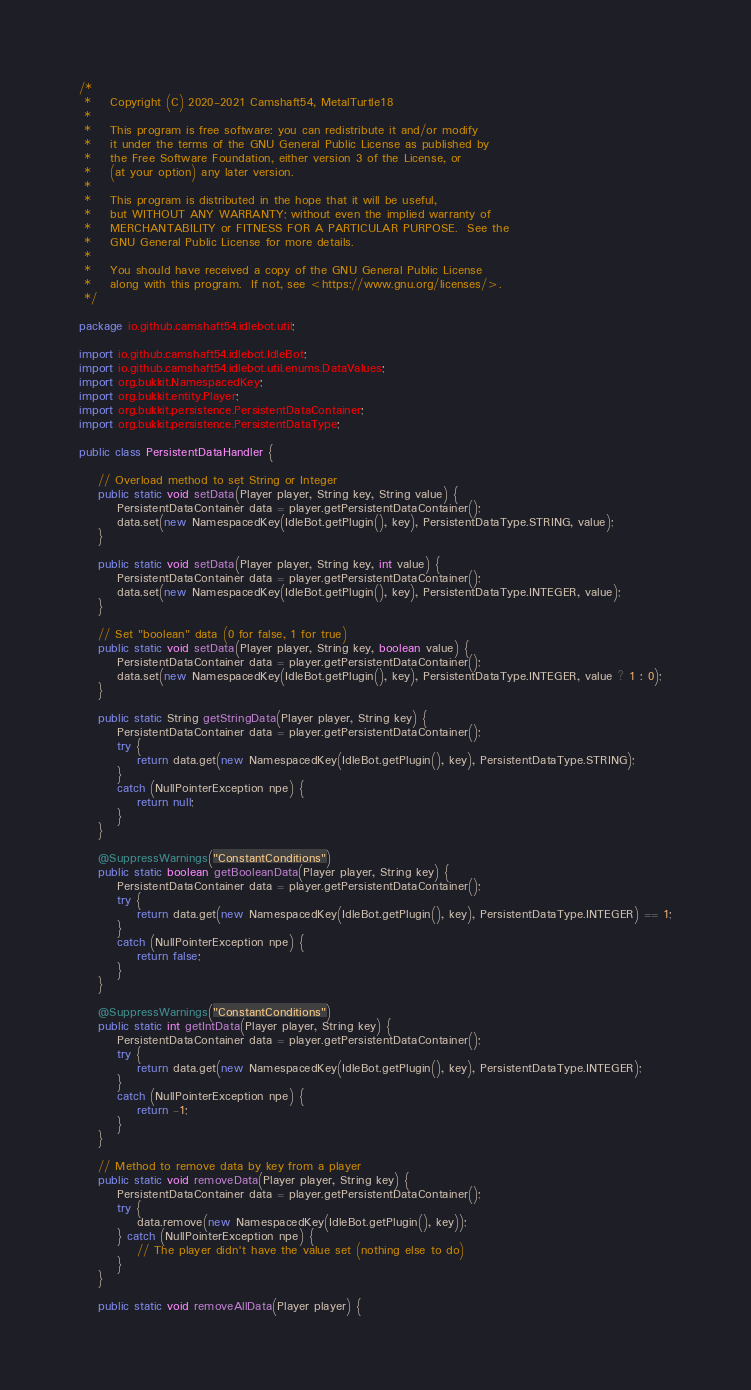Convert code to text. <code><loc_0><loc_0><loc_500><loc_500><_Java_>/*
 *    Copyright (C) 2020-2021 Camshaft54, MetalTurtle18
 *
 *    This program is free software: you can redistribute it and/or modify
 *    it under the terms of the GNU General Public License as published by
 *    the Free Software Foundation, either version 3 of the License, or
 *    (at your option) any later version.
 *
 *    This program is distributed in the hope that it will be useful,
 *    but WITHOUT ANY WARRANTY; without even the implied warranty of
 *    MERCHANTABILITY or FITNESS FOR A PARTICULAR PURPOSE.  See the
 *    GNU General Public License for more details.
 *
 *    You should have received a copy of the GNU General Public License
 *    along with this program.  If not, see <https://www.gnu.org/licenses/>.
 */

package io.github.camshaft54.idlebot.util;

import io.github.camshaft54.idlebot.IdleBot;
import io.github.camshaft54.idlebot.util.enums.DataValues;
import org.bukkit.NamespacedKey;
import org.bukkit.entity.Player;
import org.bukkit.persistence.PersistentDataContainer;
import org.bukkit.persistence.PersistentDataType;

public class PersistentDataHandler {

    // Overload method to set String or Integer
    public static void setData(Player player, String key, String value) {
        PersistentDataContainer data = player.getPersistentDataContainer();
        data.set(new NamespacedKey(IdleBot.getPlugin(), key), PersistentDataType.STRING, value);
    }

    public static void setData(Player player, String key, int value) {
        PersistentDataContainer data = player.getPersistentDataContainer();
        data.set(new NamespacedKey(IdleBot.getPlugin(), key), PersistentDataType.INTEGER, value);
    }

    // Set "boolean" data (0 for false, 1 for true)
    public static void setData(Player player, String key, boolean value) {
        PersistentDataContainer data = player.getPersistentDataContainer();
        data.set(new NamespacedKey(IdleBot.getPlugin(), key), PersistentDataType.INTEGER, value ? 1 : 0);
    }

    public static String getStringData(Player player, String key) {
        PersistentDataContainer data = player.getPersistentDataContainer();
        try {
            return data.get(new NamespacedKey(IdleBot.getPlugin(), key), PersistentDataType.STRING);
        }
        catch (NullPointerException npe) {
            return null;
        }
    }

    @SuppressWarnings("ConstantConditions")
    public static boolean getBooleanData(Player player, String key) {
        PersistentDataContainer data = player.getPersistentDataContainer();
        try {
            return data.get(new NamespacedKey(IdleBot.getPlugin(), key), PersistentDataType.INTEGER) == 1;
        }
        catch (NullPointerException npe) {
            return false;
        }
    }

    @SuppressWarnings("ConstantConditions")
    public static int getIntData(Player player, String key) {
        PersistentDataContainer data = player.getPersistentDataContainer();
        try {
            return data.get(new NamespacedKey(IdleBot.getPlugin(), key), PersistentDataType.INTEGER);
        }
        catch (NullPointerException npe) {
            return -1;
        }
    }

    // Method to remove data by key from a player
    public static void removeData(Player player, String key) {
        PersistentDataContainer data = player.getPersistentDataContainer();
        try {
            data.remove(new NamespacedKey(IdleBot.getPlugin(), key));
        } catch (NullPointerException npe) {
            // The player didn't have the value set (nothing else to do)
        }
    }

    public static void removeAllData(Player player) {</code> 